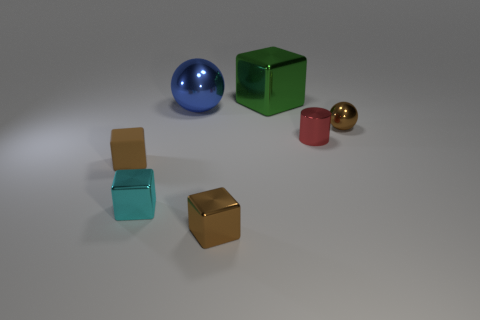Subtract all cyan cylinders. How many brown cubes are left? 2 Subtract 2 blocks. How many blocks are left? 2 Subtract all cyan cubes. How many cubes are left? 3 Subtract all big cubes. How many cubes are left? 3 Add 2 tiny blue blocks. How many objects exist? 9 Subtract all yellow blocks. Subtract all blue cylinders. How many blocks are left? 4 Subtract all small red metallic cubes. Subtract all large objects. How many objects are left? 5 Add 4 tiny brown metallic things. How many tiny brown metallic things are left? 6 Add 1 blue rubber cylinders. How many blue rubber cylinders exist? 1 Subtract 0 red cubes. How many objects are left? 7 